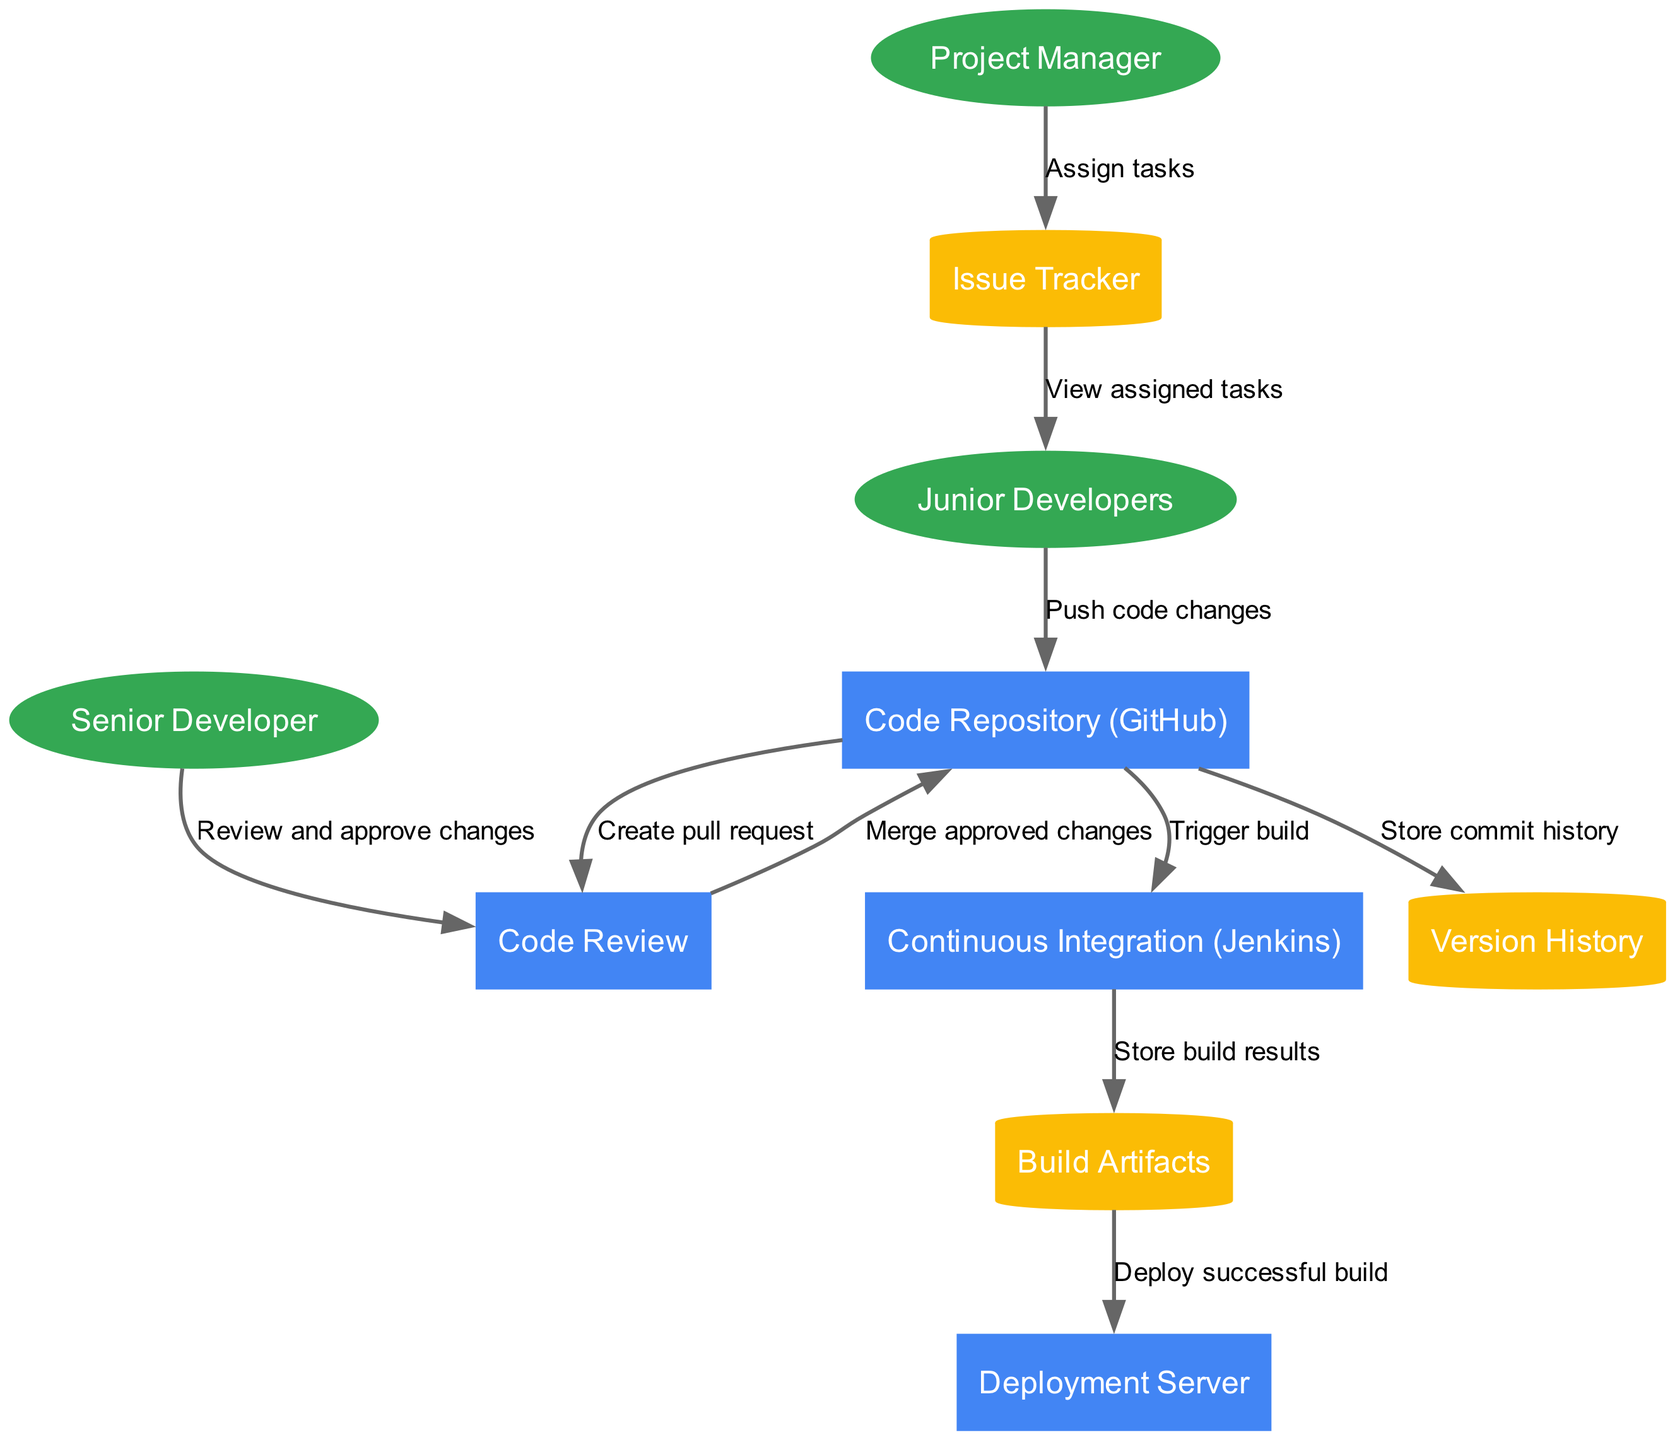What are the external entities involved in this system? The external entities listed in the diagram are Junior Developers, Senior Developer, and Project Manager. These are displayed as ellipses in the diagram which typically represent external inputs or users interacting with the system.
Answer: Junior Developers, Senior Developer, Project Manager How many processes are defined in the diagram? There are four processes identified in the diagram: Code Repository (GitHub), Code Review, Continuous Integration (Jenkins), and Deployment Server. This can be counted directly from the rectangle nodes in the diagram.
Answer: 4 What is the flow from the Code Repository to Continuous Integration? The flow from Code Repository (GitHub) to Continuous Integration (Jenkins) is labeled "Trigger build." This indicates that after code is merged into the repository, it will initiate a build process in Jenkins.
Answer: Trigger build Who reviews the code changes before they are merged? The Senior Developer is responsible for reviewing and approving changes as indicated by the flow from Senior Developer to Code Review. This shows the critical step of code validation before merging.
Answer: Senior Developer How many data flows originate from Junior Developers? There are two data flows originating from Junior Developers. One flow is "Push code changes" to the Code Repository and the other is "View assigned tasks" which leads back from Issue Tracker to Junior Developers. This gives a clear view of their interactions with the system.
Answer: 2 What happens to build results after they are created? After the build results are created in Continuous Integration (Jenkins), they are stored in Build Artifacts. This clearly shows that build results are kept for later use or reference.
Answer: Store build results What task is assigned by the Project Manager? The Project Manager assigns tasks as shown in the flow from Project Manager to Issue Tracker. This flow indicates the role of the Project Manager in managing tasks within the team.
Answer: Assign tasks What is the final destination of successful builds? The final destination for successful builds is the Deployment Server, as shown by the flow "Deploy successful build" coming from Build Artifacts. This signifies where the successful artifacts are sent for deployment.
Answer: Deployment Server 